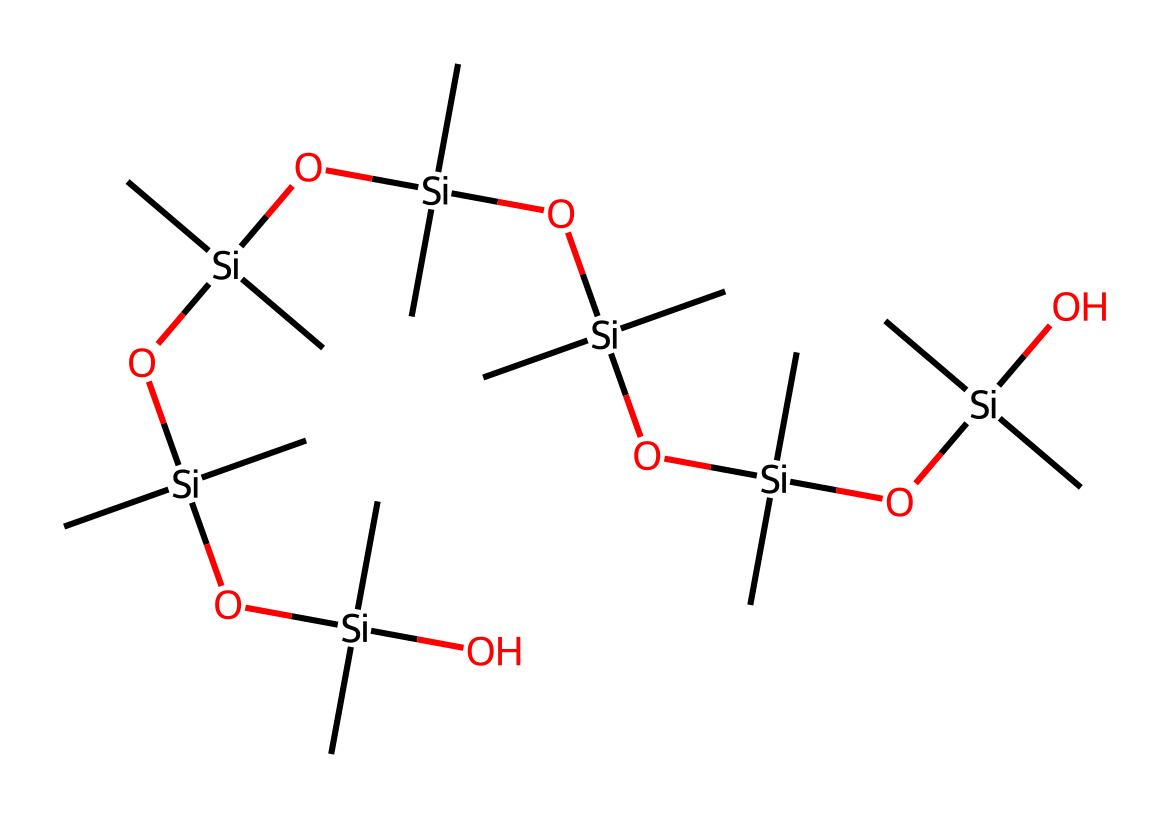what is the total number of silicon atoms in the structure? The provided SMILES represents a structure with eight silicon (Si) atoms, which can be counted from the individual instances of "[Si]" in the chain.
Answer: eight how many oxygen atoms are present in this chemical? In the given SMILES, by identifying each occurrence of "O" associated with the silicon atoms, there are seven oxygen (O) atoms present in the structure.
Answer: seven what type of functional groups are present in the molecule? The molecule primarily contains silanol functional groups (Si-OH), which can be inferred from the Si being connected to oxygen atoms.
Answer: silanol what is the degree of branching in the molecular structure? The structure shows a highly branched arrangement with multiple silicon atoms connected by oxygen bridges, indicative of a branched polysiloxane architecture.
Answer: highly branched how does the presence of silicon atoms affect the thermal stability of this compound? Silicon's properties typically contribute to increased thermal stability due to its strong Si-O bond, which is more thermally stable than carbon-covalent bonds. Hence, this compound is expected to exhibit good thermal stability.
Answer: good thermal stability what type of polymer does this structure represent? The chemical structure resembles a siloxane polymer due to the alternating silicon and oxygen atoms, commonly seen in silicone-based materials.
Answer: siloxane polymer what are the potential applications of this silicone-based PPE material? Due to its flexible and water-repellent properties, this silicone-based material is often used in medical gloves, chemical-resistant clothing, and other personal protective equipment applications.
Answer: medical gloves 